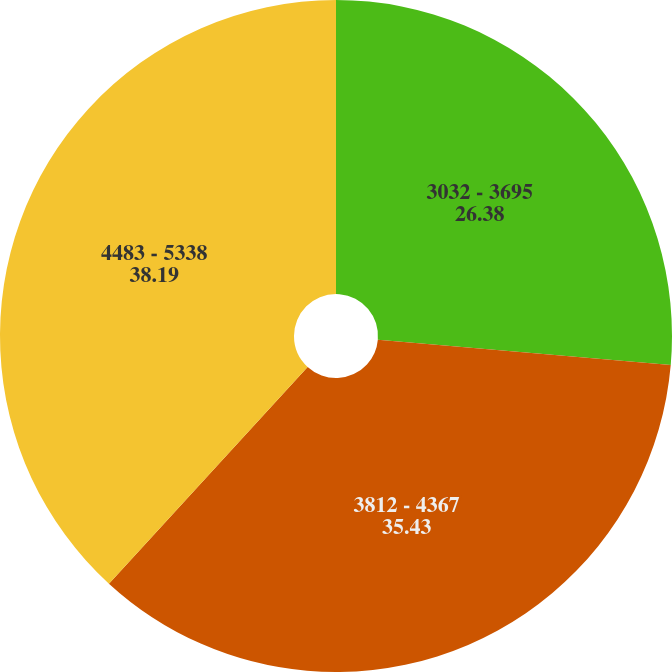Convert chart. <chart><loc_0><loc_0><loc_500><loc_500><pie_chart><fcel>3032 - 3695<fcel>3812 - 4367<fcel>4483 - 5338<nl><fcel>26.38%<fcel>35.43%<fcel>38.19%<nl></chart> 